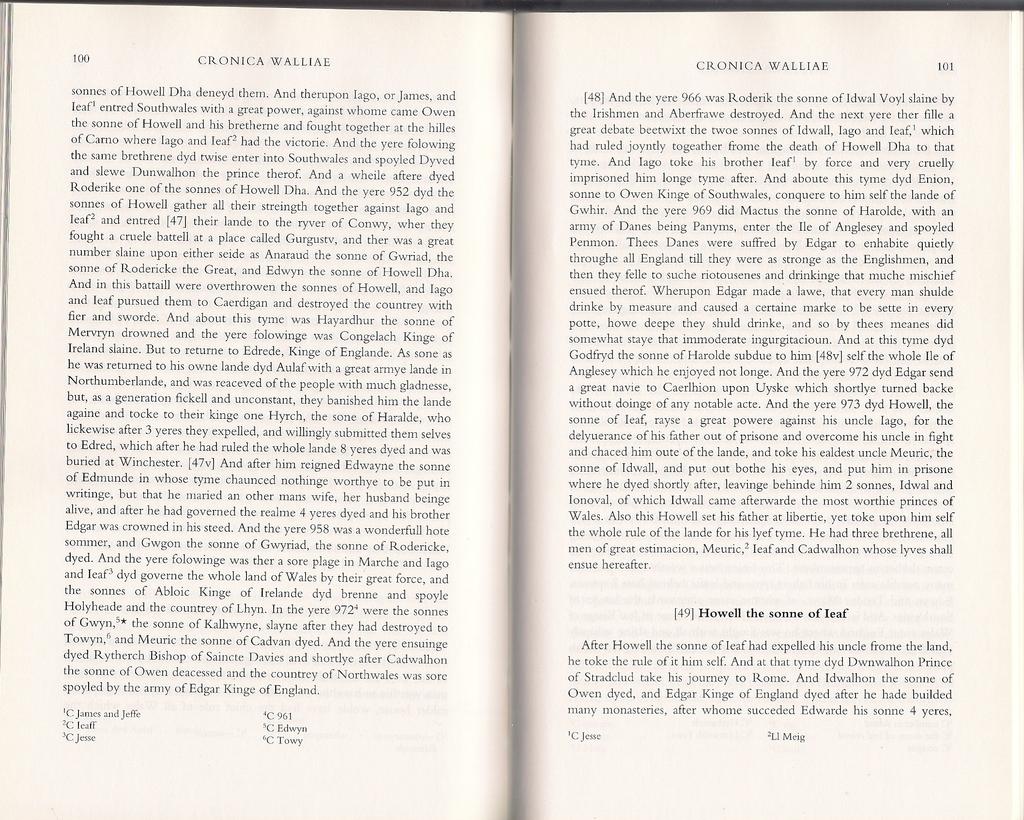What are the number of the two pages?
Your response must be concise. 100 101. What is on the bottom of the second page?
Give a very brief answer. Li meig. 